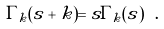<formula> <loc_0><loc_0><loc_500><loc_500>\Gamma _ { k } ( s + k ) = s \Gamma _ { k } ( s ) \ .</formula> 